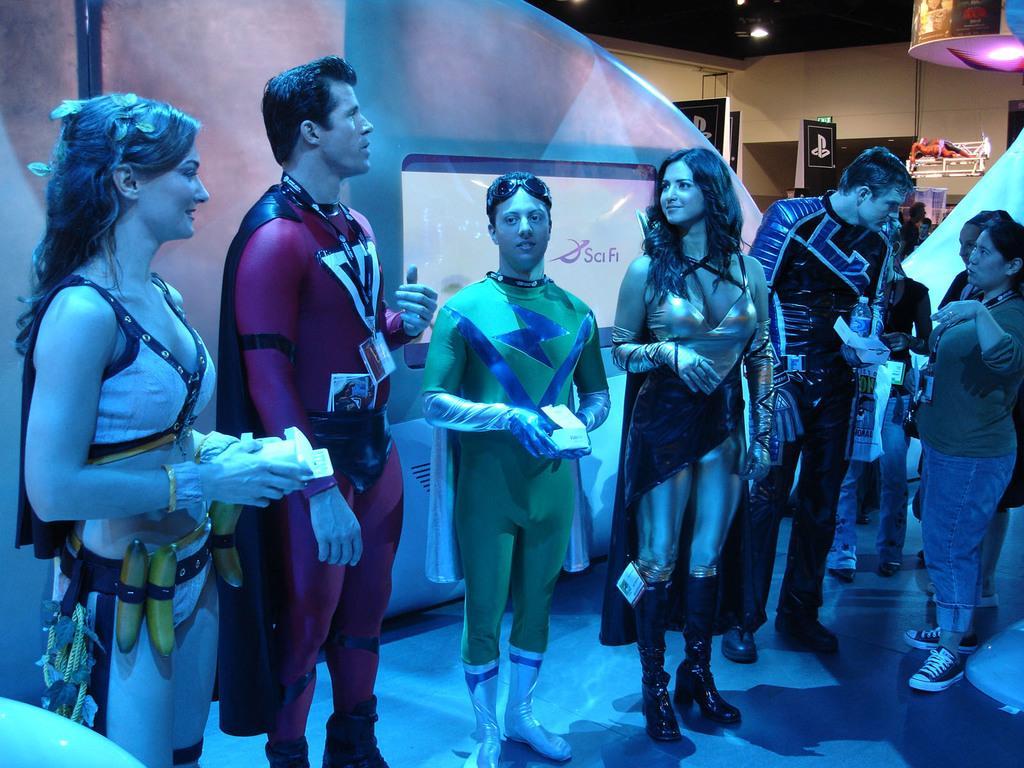In one or two sentences, can you explain what this image depicts? In this picture there is a man who is wearing red dress, beside him there is another man who is wearing green dress and he is holding a box. On the left there is a woman who is wearing white dress and she is holding some bananas. On the right there is a woman who is holding the papers, beside him there is a man who is wearing black dress and holding the water bottle. Behind them i can see some cloth partition. In the top right corner i can see some objects on the racks. 